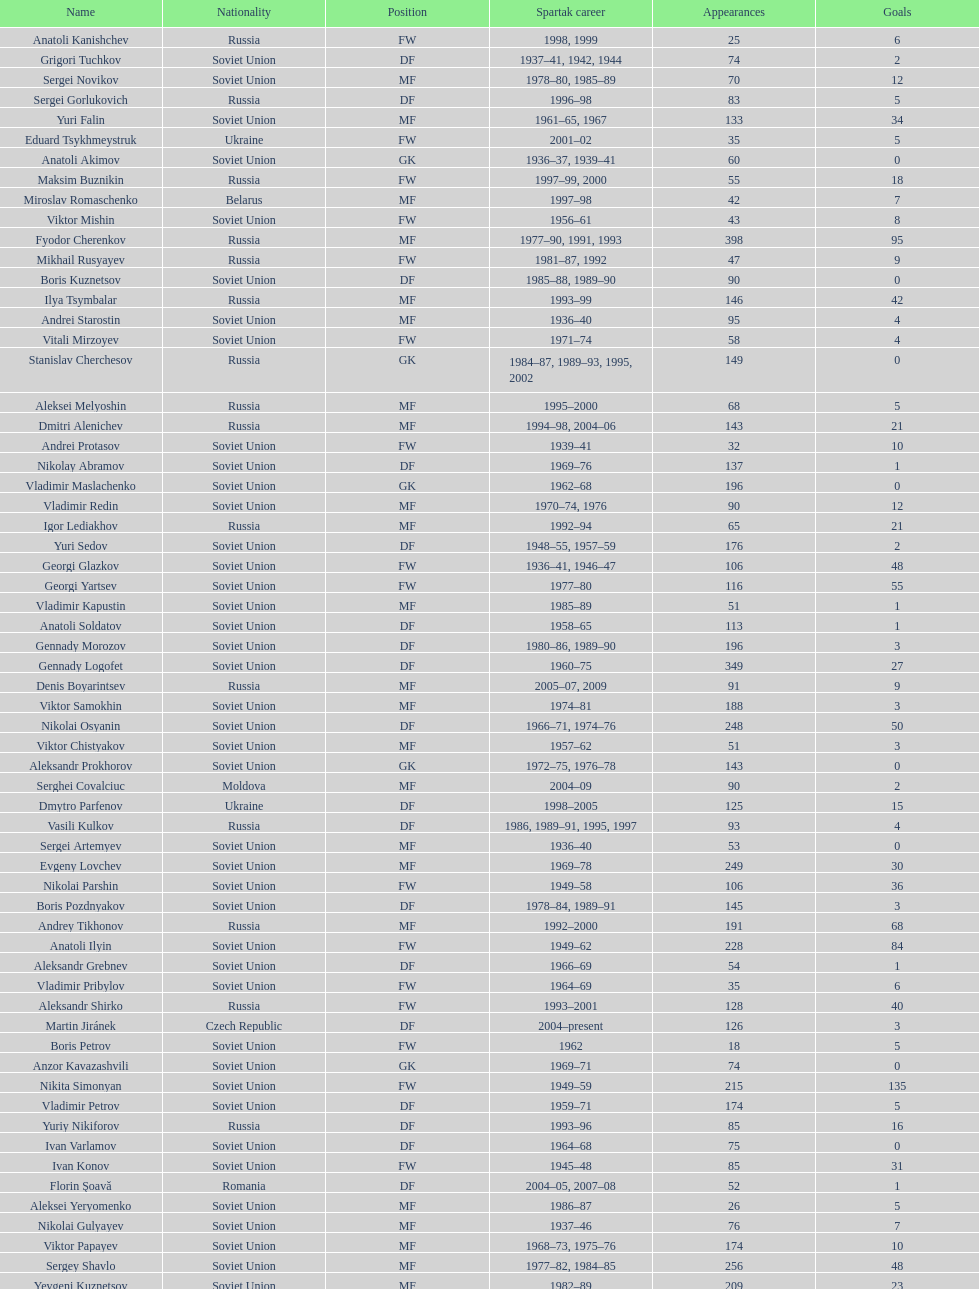Which player has the most appearances with the club? Fyodor Cherenkov. 